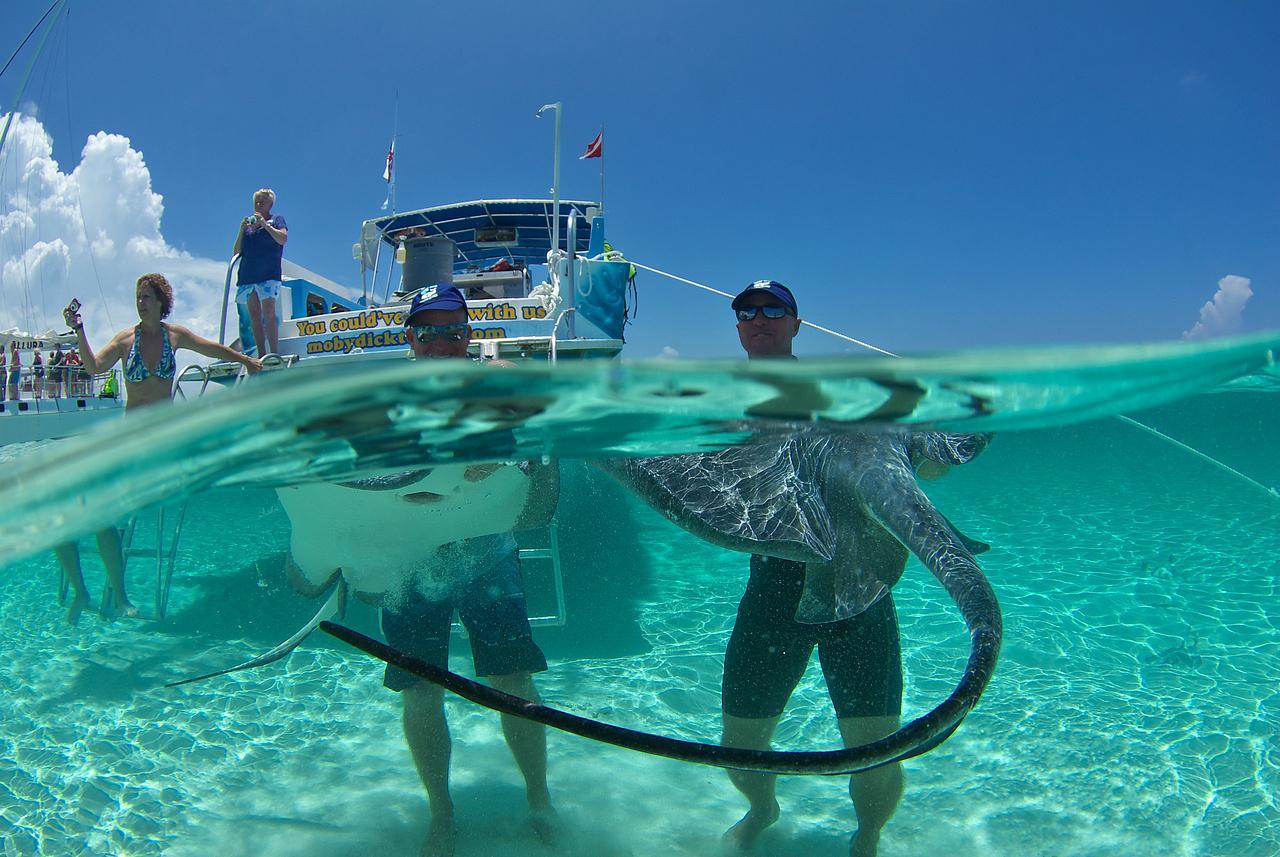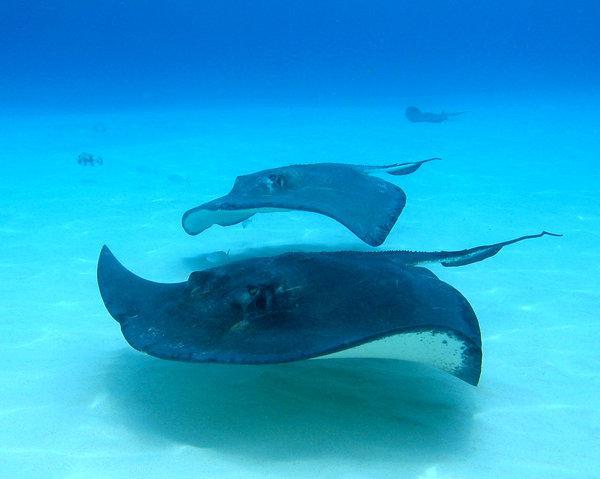The first image is the image on the left, the second image is the image on the right. Evaluate the accuracy of this statement regarding the images: "There is at least one person in the water with at least one manta ray.". Is it true? Answer yes or no. Yes. The first image is the image on the left, the second image is the image on the right. Evaluate the accuracy of this statement regarding the images: "Two or more people are in very clear ocean water with manta rays swimming around them.". Is it true? Answer yes or no. Yes. 